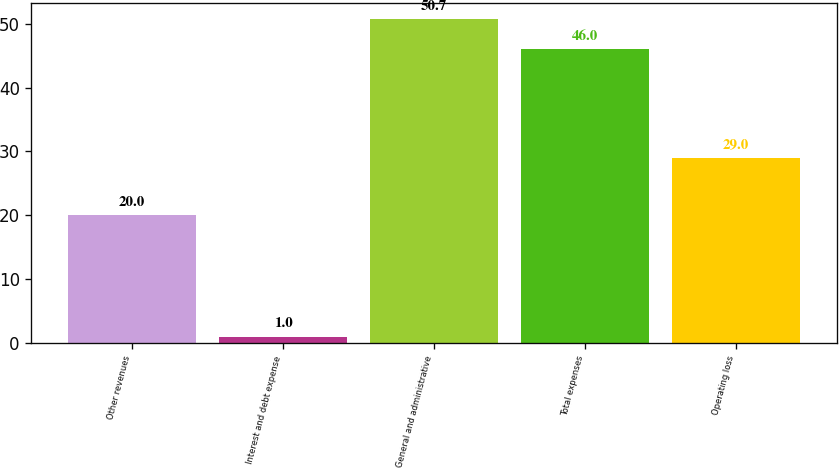Convert chart to OTSL. <chart><loc_0><loc_0><loc_500><loc_500><bar_chart><fcel>Other revenues<fcel>Interest and debt expense<fcel>General and administrative<fcel>Total expenses<fcel>Operating loss<nl><fcel>20<fcel>1<fcel>50.7<fcel>46<fcel>29<nl></chart> 